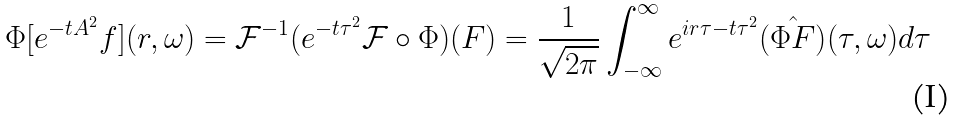Convert formula to latex. <formula><loc_0><loc_0><loc_500><loc_500>\Phi [ e ^ { - t A ^ { 2 } } f ] ( r , \omega ) = \mathcal { F } ^ { - 1 } ( e ^ { - t \tau ^ { 2 } } \mathcal { F } \circ \Phi ) ( F ) = \frac { 1 } { \sqrt { 2 \pi } } \int _ { - \infty } ^ { \infty } e ^ { i r \tau - t \tau ^ { 2 } } \hat { ( \Phi F ) } ( \tau , \omega ) d \tau</formula> 